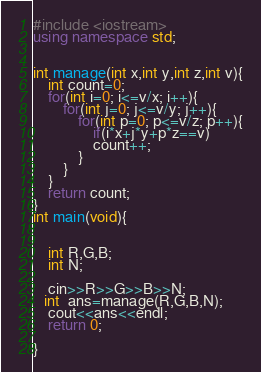Convert code to text. <code><loc_0><loc_0><loc_500><loc_500><_C++_>#include <iostream>
using namespace std;


int manage(int x,int y,int z,int v){
    int count=0;
    for(int i=0; i<=v/x; i++){
        for(int j=0; j<=v/y; j++){
            for(int p=0; p<=v/z; p++){
                if(i*x+j*y+p*z==v)
                count++;
            }
        }
    }
    return count;
}
int main(void){
    

    int R,G,B;
    int N;

    cin>>R>>G>>B>>N;
   int  ans=manage(R,G,B,N);
    cout<<ans<<endl;
    return 0;

}
</code> 